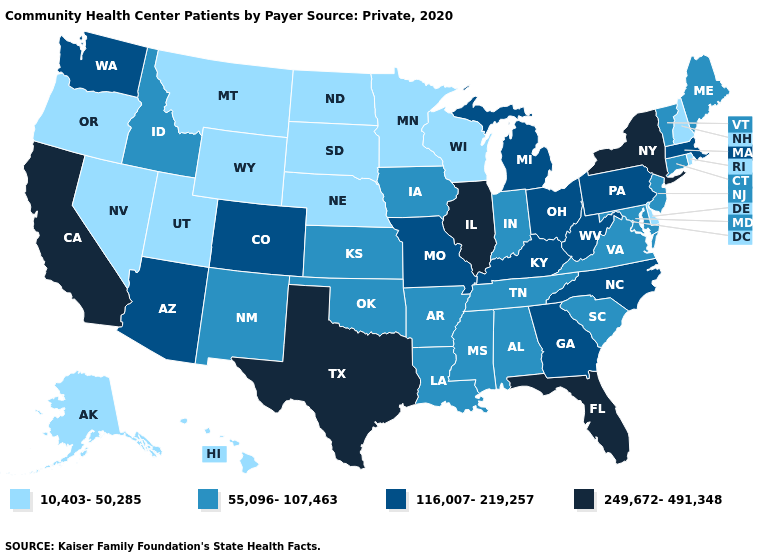What is the value of New York?
Keep it brief. 249,672-491,348. What is the lowest value in the Northeast?
Quick response, please. 10,403-50,285. Name the states that have a value in the range 249,672-491,348?
Quick response, please. California, Florida, Illinois, New York, Texas. Does California have the lowest value in the West?
Be succinct. No. What is the value of Rhode Island?
Answer briefly. 10,403-50,285. Which states hav the highest value in the West?
Give a very brief answer. California. Does the first symbol in the legend represent the smallest category?
Quick response, please. Yes. Which states have the highest value in the USA?
Concise answer only. California, Florida, Illinois, New York, Texas. What is the lowest value in the MidWest?
Short answer required. 10,403-50,285. Name the states that have a value in the range 249,672-491,348?
Write a very short answer. California, Florida, Illinois, New York, Texas. Does Texas have the highest value in the South?
Answer briefly. Yes. What is the value of Maryland?
Concise answer only. 55,096-107,463. Among the states that border New York , does Pennsylvania have the highest value?
Give a very brief answer. Yes. Does West Virginia have the highest value in the USA?
Short answer required. No. Among the states that border Connecticut , does New York have the highest value?
Short answer required. Yes. 